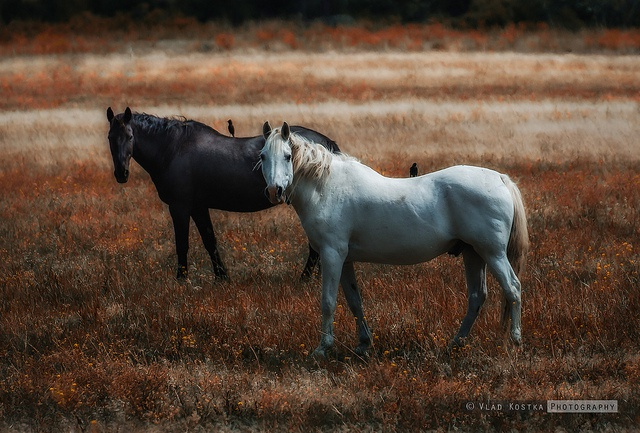Describe the objects in this image and their specific colors. I can see horse in black, purple, and darkgray tones, horse in black and gray tones, bird in black, gray, and maroon tones, and bird in black, gray, and brown tones in this image. 